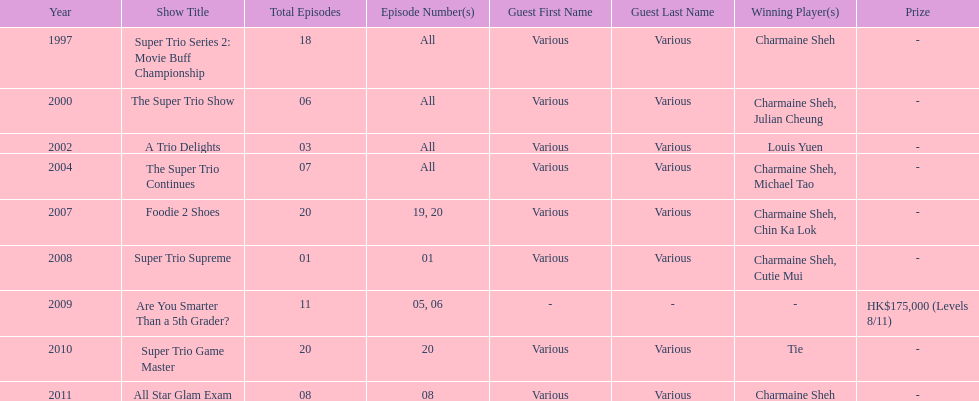How long has it been since chermaine sheh first appeared on a variety show? 17 years. 